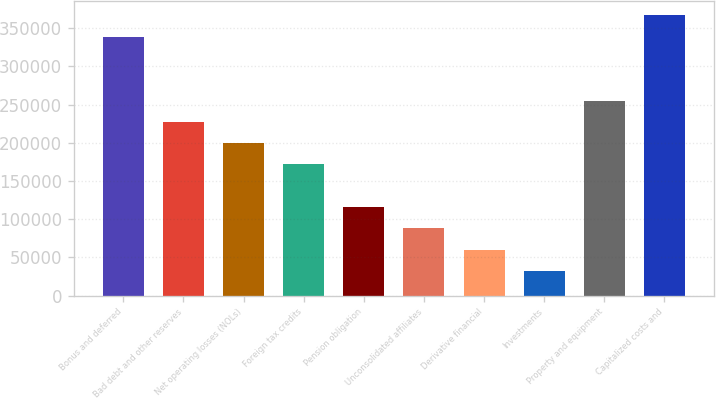<chart> <loc_0><loc_0><loc_500><loc_500><bar_chart><fcel>Bonus and deferred<fcel>Bad debt and other reserves<fcel>Net operating losses (NOLs)<fcel>Foreign tax credits<fcel>Pension obligation<fcel>Unconsolidated affiliates<fcel>Derivative financial<fcel>Investments<fcel>Property and equipment<fcel>Capitalized costs and<nl><fcel>338872<fcel>227440<fcel>199581<fcel>171723<fcel>116007<fcel>88148.6<fcel>60290.4<fcel>32432.2<fcel>255298<fcel>366731<nl></chart> 